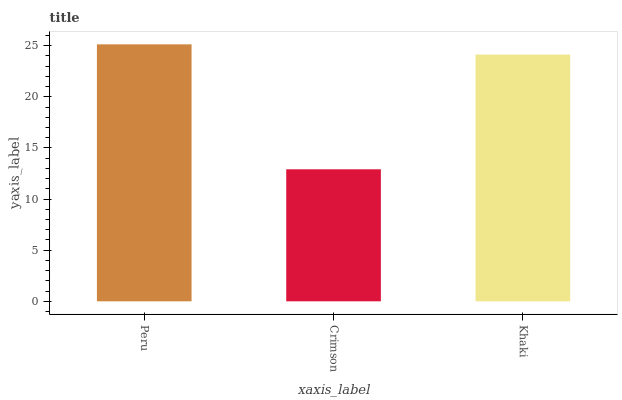Is Crimson the minimum?
Answer yes or no. Yes. Is Peru the maximum?
Answer yes or no. Yes. Is Khaki the minimum?
Answer yes or no. No. Is Khaki the maximum?
Answer yes or no. No. Is Khaki greater than Crimson?
Answer yes or no. Yes. Is Crimson less than Khaki?
Answer yes or no. Yes. Is Crimson greater than Khaki?
Answer yes or no. No. Is Khaki less than Crimson?
Answer yes or no. No. Is Khaki the high median?
Answer yes or no. Yes. Is Khaki the low median?
Answer yes or no. Yes. Is Peru the high median?
Answer yes or no. No. Is Peru the low median?
Answer yes or no. No. 